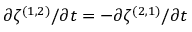Convert formula to latex. <formula><loc_0><loc_0><loc_500><loc_500>\partial { \zeta ^ { ( 1 , 2 ) } } / \partial { t } = - \partial { \zeta ^ { ( 2 , 1 ) } } / \partial { t }</formula> 